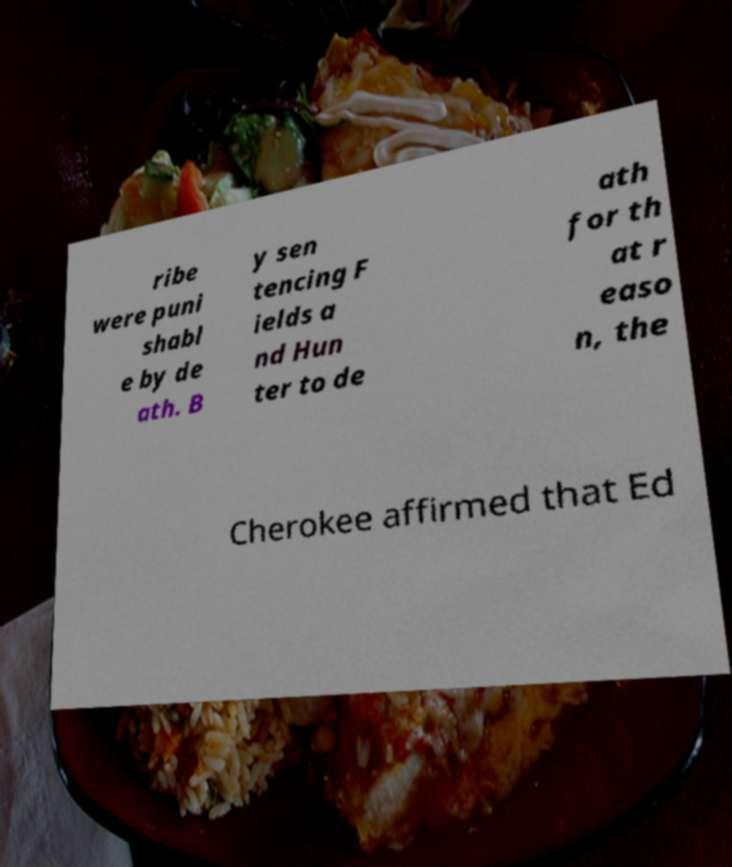Could you assist in decoding the text presented in this image and type it out clearly? ribe were puni shabl e by de ath. B y sen tencing F ields a nd Hun ter to de ath for th at r easo n, the Cherokee affirmed that Ed 